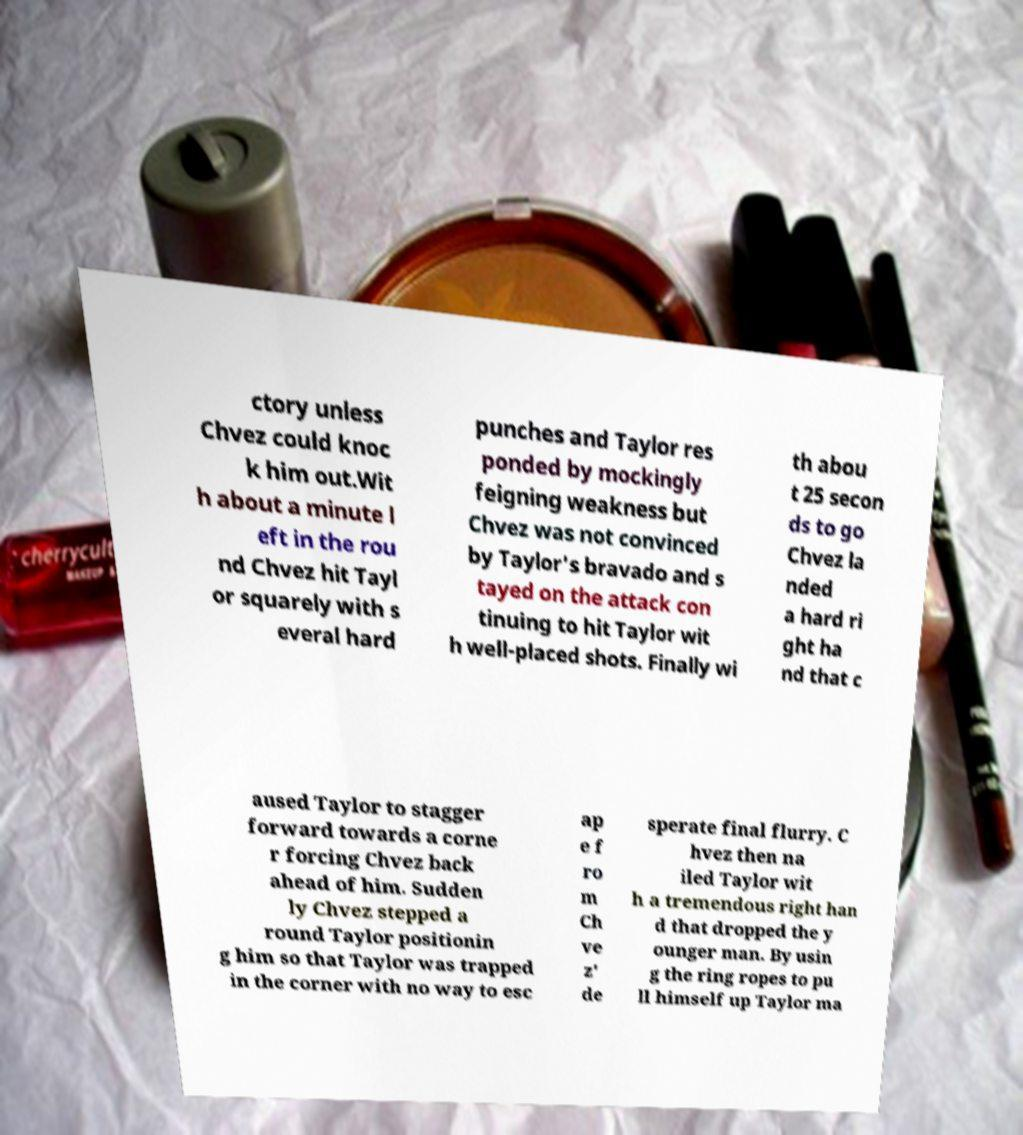Could you assist in decoding the text presented in this image and type it out clearly? ctory unless Chvez could knoc k him out.Wit h about a minute l eft in the rou nd Chvez hit Tayl or squarely with s everal hard punches and Taylor res ponded by mockingly feigning weakness but Chvez was not convinced by Taylor's bravado and s tayed on the attack con tinuing to hit Taylor wit h well-placed shots. Finally wi th abou t 25 secon ds to go Chvez la nded a hard ri ght ha nd that c aused Taylor to stagger forward towards a corne r forcing Chvez back ahead of him. Sudden ly Chvez stepped a round Taylor positionin g him so that Taylor was trapped in the corner with no way to esc ap e f ro m Ch ve z' de sperate final flurry. C hvez then na iled Taylor wit h a tremendous right han d that dropped the y ounger man. By usin g the ring ropes to pu ll himself up Taylor ma 